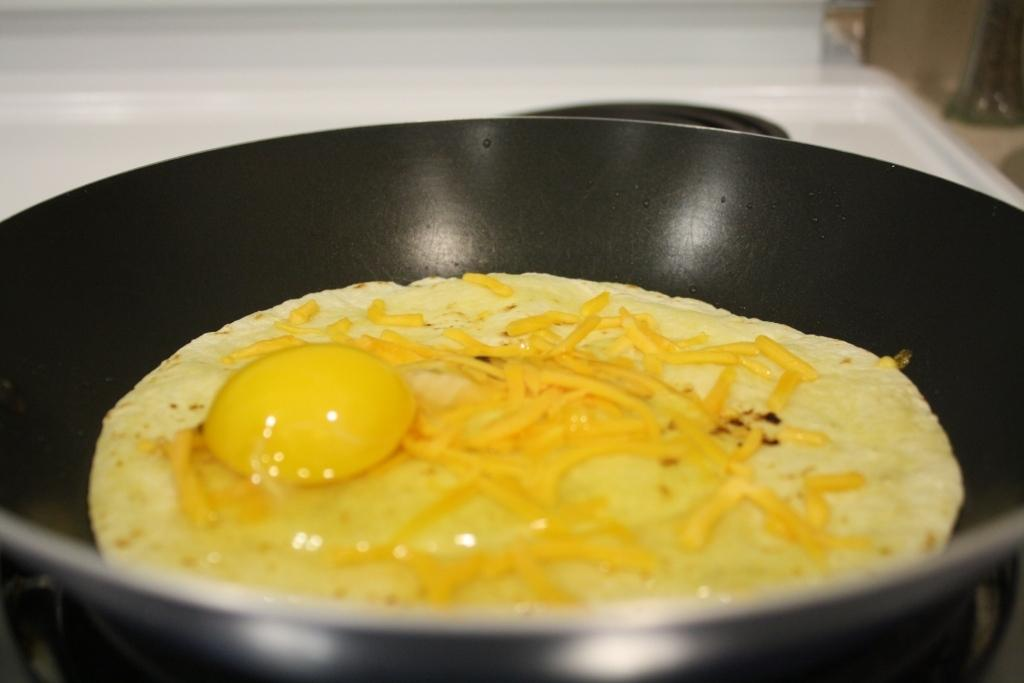What is in the frying pan that is visible in the image? There are food items in a frying pan in the image. What type of friction can be seen between the food items in the frying pan? There is no specific type of friction visible between the food items in the frying pan, as the image does not provide enough detail to determine the nature of any friction. 